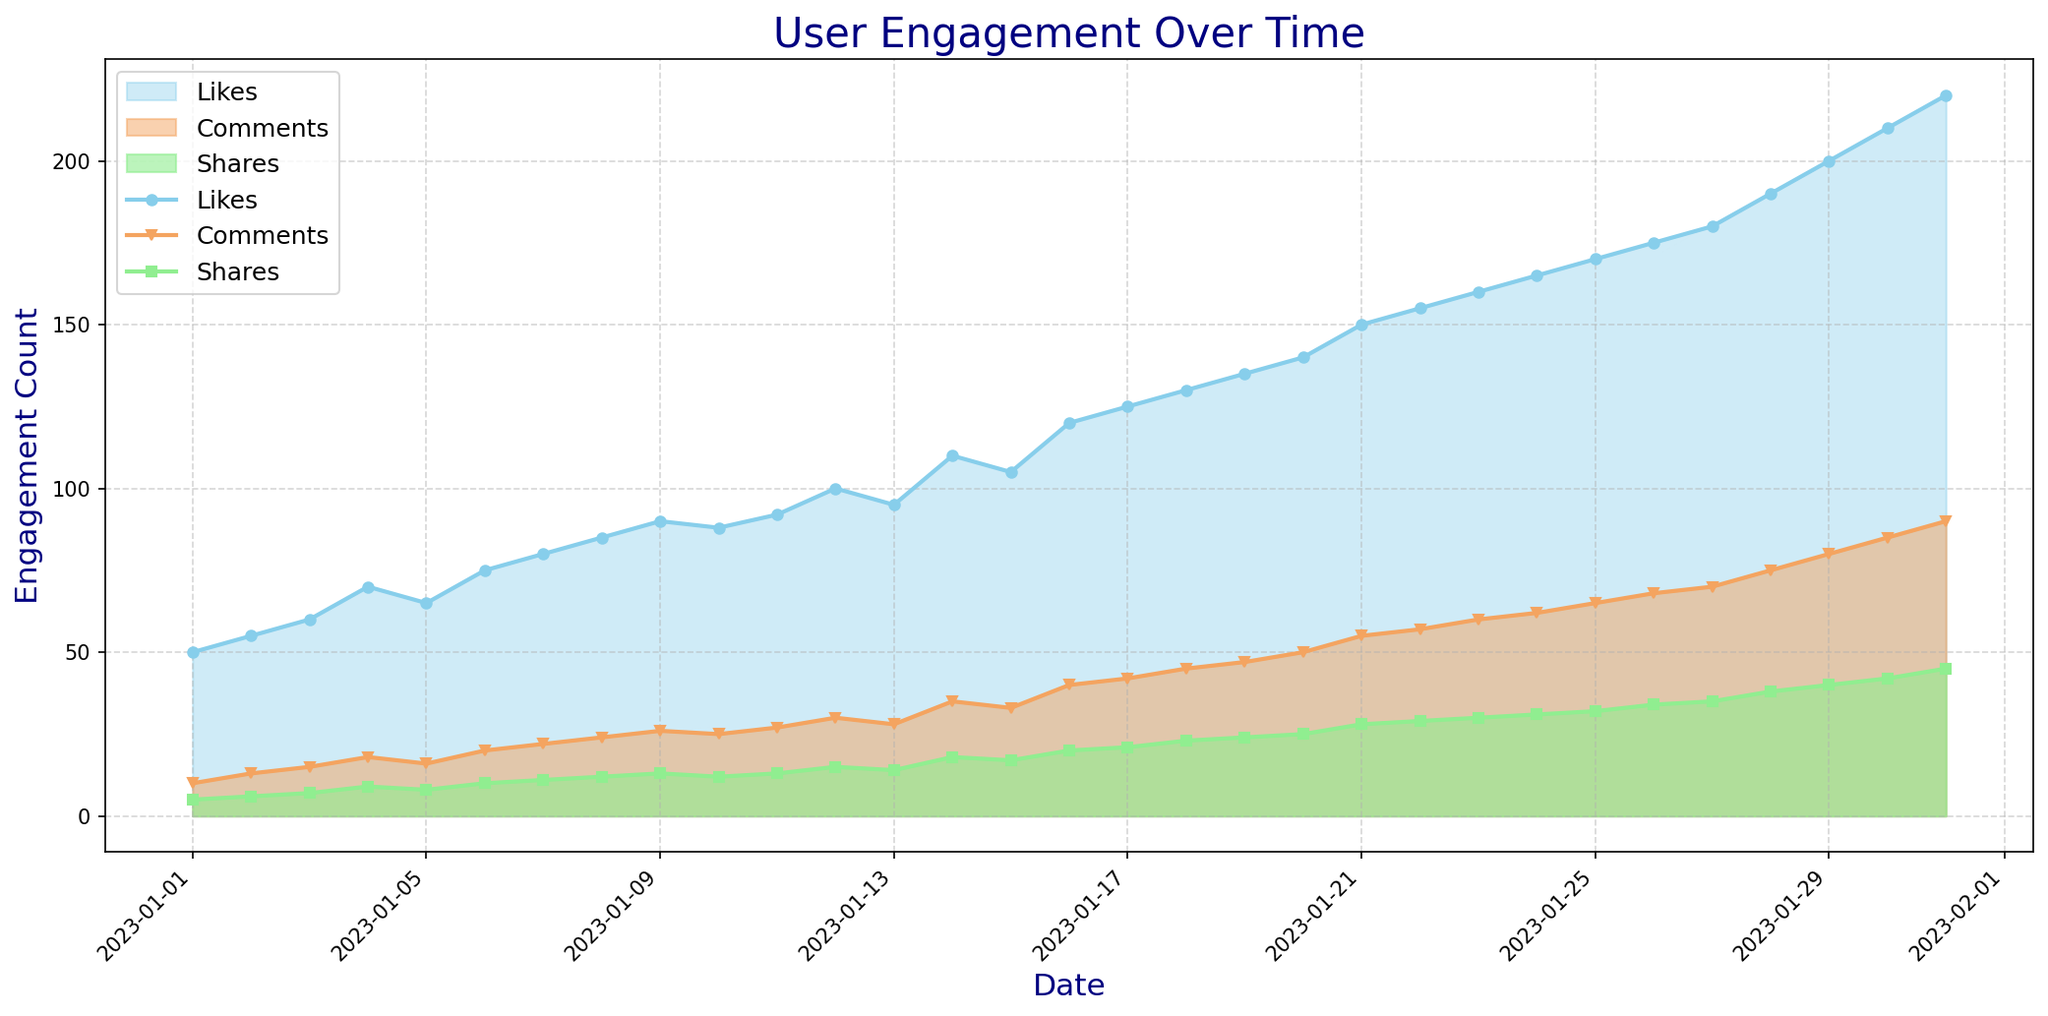what is the engagement count on 2023-01-15 for likes, comments, and shares respectively? Refer to the peaks marked on the data line for the date 2023-01-15. Check the height or position corresponding to likes, comments, and shares. On 2023-01-15, the engagement counts are likes: 105, comments: 33, shares: 17
Answer: 105, 33, 17 Which reaction type has the largest increase in engagement from 2023-01-15 to 2023-01-16? Observe the slopes between 2023-01-15 and 2023-01-16 for each reaction type. Calculate the differences: likes: 120-105 = 15, comments: 40-33 = 7, shares: 20-17 = 3. Likes have the largest increase.
Answer: Likes Which day saw the highest total user engagement (sum of likes, comments, and shares)? Calculate the total engagement for each day by summing all reaction types and identify the day with the highest count. The respective sums are: 2023-01-31: likes: 220, comments: 90, shares: 45; 220 + 90 + 45 = 355. This day has the highest sum of engagements.
Answer: 2023-01-31 On what date did the number of likes first exceed 100? Locate the position in the chart where the likes first go above the 100 mark by spotting the data point exceeding this value. The likes exceed 100 on 2023-01-12.
Answer: 2023-01-12 How many times did the number of comments equal or exceed 50? Count the frequency of points where comments meet or exceed 50 by referring to their height equivalent. Comments reached or surpass 50 on 2023-01-20, 2023-01-21, 2023-01-22, 2023-01-23, 2023-01-24, 2023-01-25, 2023-01-26, 2023-01-27, 2023-01-28, 2023-01-29, 2023-01-30, and 2023-01-31. There are 12 such instances.
Answer: 12 What is the average increase in the number of shares per day over the entire period? Calculate daily increase in shares by subtracting each day’s share from the previous one, then average these values. The sum of daily increases is: (6-5) + (7-6) + (9-7) + (8-9) + (10-8) + (11-10) + (12-11) + (13-12) + (12-13) + (13-12) + (15-13) + (14-15) + (18-14) + (17-18) + (20-17) + (21-20) + (23-21) + (24-23) + (25-24) + (28-25) + (29-28) + (30-29) + (31-30) + (32-31) + (34-32) + (35-34) + (38-35) + (40-38) + (42-40) + (45-42) = 52 and divide by 30 days: 52/30 ≈ 1.73
Answer: 1.73 